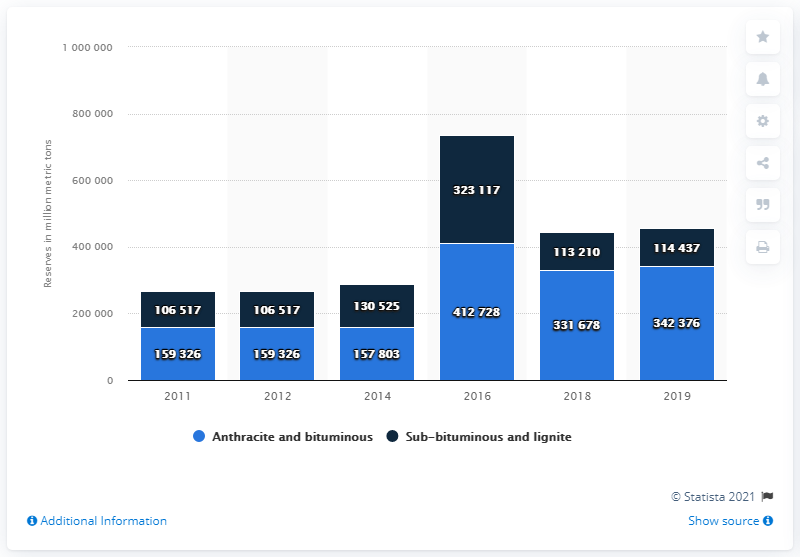Draw attention to some important aspects in this diagram. In 2019, China had a total of 342,376 metric tons of anthracite and bituminous coal. 